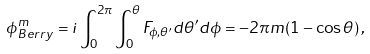<formula> <loc_0><loc_0><loc_500><loc_500>\phi ^ { m } _ { B e r r y } = i \int _ { 0 } ^ { 2 \pi } \int _ { 0 } ^ { \theta } F _ { \phi , \theta ^ { \prime } } d \theta ^ { \prime } d \phi = - 2 \pi m ( 1 - \cos { \theta } ) \, ,</formula> 